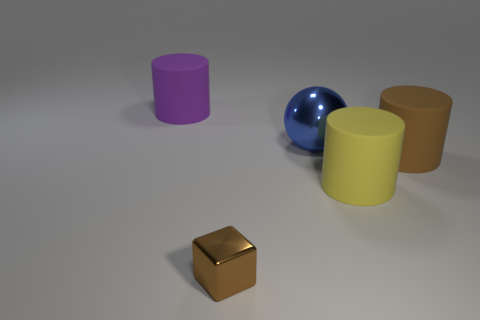How many other spheres are the same size as the shiny ball?
Ensure brevity in your answer.  0. What is the shape of the rubber thing that is the same color as the tiny metal cube?
Provide a succinct answer. Cylinder. What number of objects are cylinders that are on the right side of the yellow matte object or large yellow objects?
Your response must be concise. 2. Is the number of big yellow cylinders less than the number of small yellow cylinders?
Give a very brief answer. No. What shape is the purple thing that is the same material as the large yellow object?
Provide a short and direct response. Cylinder. There is a tiny brown metal cube; are there any objects behind it?
Provide a succinct answer. Yes. Are there fewer big yellow rubber cylinders left of the large purple cylinder than tiny purple matte spheres?
Your answer should be compact. No. What material is the large blue thing?
Your answer should be very brief. Metal. What is the color of the large metallic thing?
Keep it short and to the point. Blue. What color is the matte cylinder that is on the left side of the large brown cylinder and to the right of the big purple thing?
Keep it short and to the point. Yellow. 